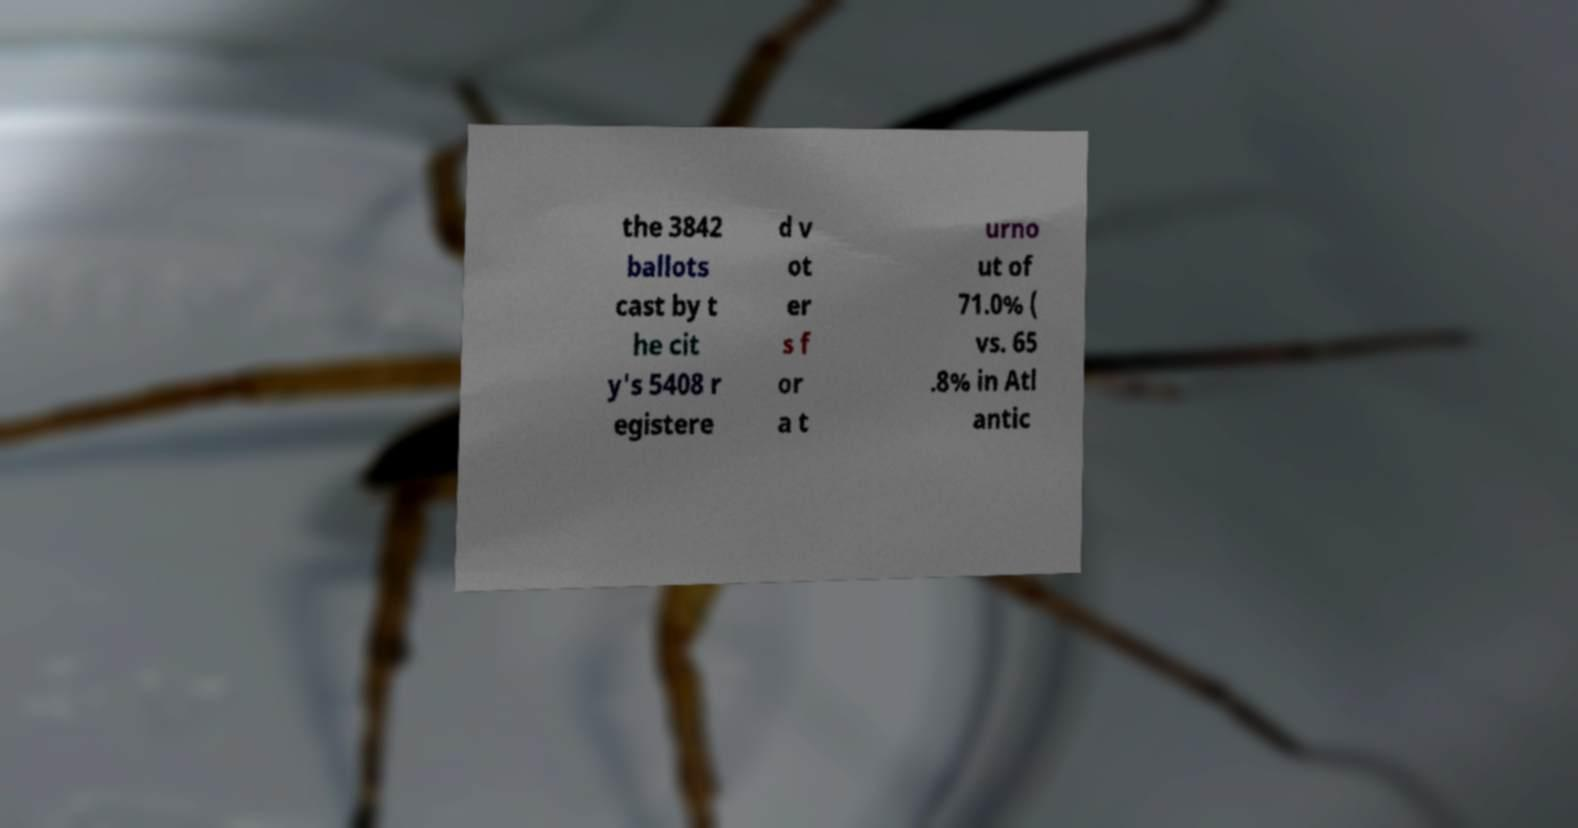Please read and relay the text visible in this image. What does it say? the 3842 ballots cast by t he cit y's 5408 r egistere d v ot er s f or a t urno ut of 71.0% ( vs. 65 .8% in Atl antic 